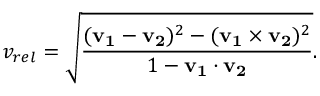Convert formula to latex. <formula><loc_0><loc_0><loc_500><loc_500>v _ { r e l } = { \sqrt { \frac { ( v _ { 1 } - v _ { 2 } ) ^ { 2 } - ( v _ { 1 } \times v _ { 2 } ) ^ { 2 } } { 1 - v _ { 1 } \cdot v _ { 2 } } } } .</formula> 